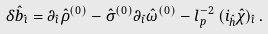<formula> <loc_0><loc_0><loc_500><loc_500>\delta { \hat { b } } _ { \hat { \imath } } = \partial _ { \hat { \imath } } { \hat { \rho } } ^ { ( 0 ) } - { \hat { \sigma } } ^ { ( 0 ) } \partial _ { \hat { \imath } } { \hat { \omega } } ^ { ( 0 ) } - l _ { p } ^ { - 2 } \, ( i _ { \hat { h } } { \hat { \chi } } ) _ { \hat { \imath } } \, .</formula> 